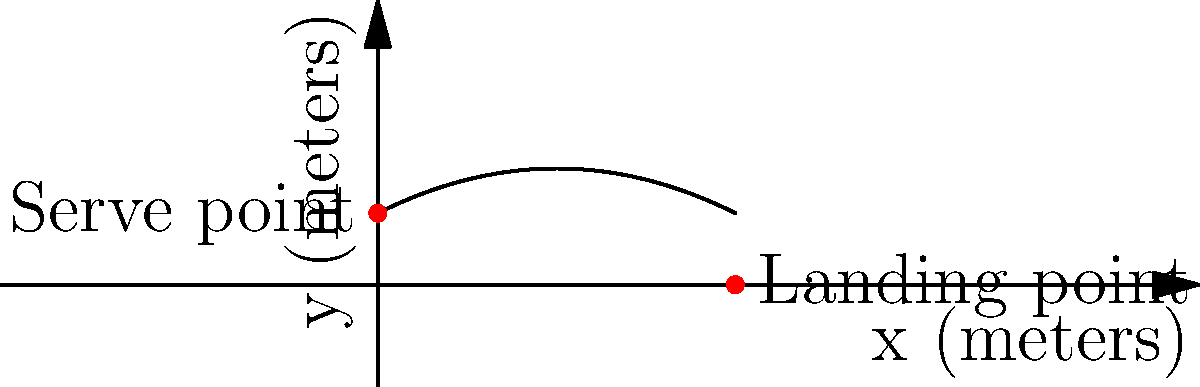During a Loyola Ramblers volleyball match, a player serves the ball from a height of 2 meters. The ball's trajectory follows a parabolic path described by the equation $y = -0.05x^2 + 0.5x + 2$, where $x$ and $y$ are measured in meters. If the ball lands 10 meters away from the server, what is the maximum height reached by the ball during its flight? To find the maximum height of the ball's trajectory, we need to follow these steps:

1) The parabola's equation is given as $y = -0.05x^2 + 0.5x + 2$

2) To find the maximum point, we need to find the vertex of the parabola. For a quadratic equation in the form $y = ax^2 + bx + c$, the x-coordinate of the vertex is given by $x = -\frac{b}{2a}$

3) In our equation, $a = -0.05$ and $b = 0.5$. Let's substitute these values:

   $x = -\frac{0.5}{2(-0.05)} = -\frac{0.5}{-0.1} = 5$ meters

4) This means the ball reaches its maximum height when it's 5 meters away from the server.

5) To find the maximum height, we substitute $x = 5$ into our original equation:

   $y = -0.05(5)^2 + 0.5(5) + 2$
   $y = -0.05(25) + 2.5 + 2$
   $y = -1.25 + 2.5 + 2$
   $y = 3.25$ meters

Therefore, the maximum height reached by the ball is 3.25 meters.
Answer: 3.25 meters 